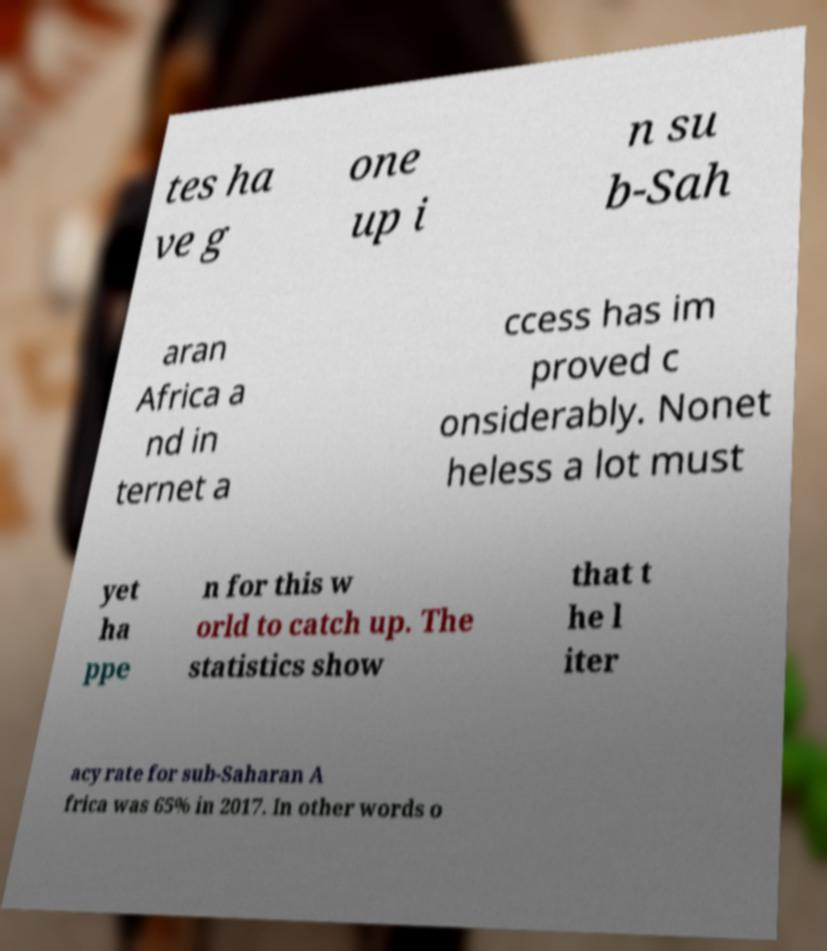Please identify and transcribe the text found in this image. tes ha ve g one up i n su b-Sah aran Africa a nd in ternet a ccess has im proved c onsiderably. Nonet heless a lot must yet ha ppe n for this w orld to catch up. The statistics show that t he l iter acy rate for sub-Saharan A frica was 65% in 2017. In other words o 